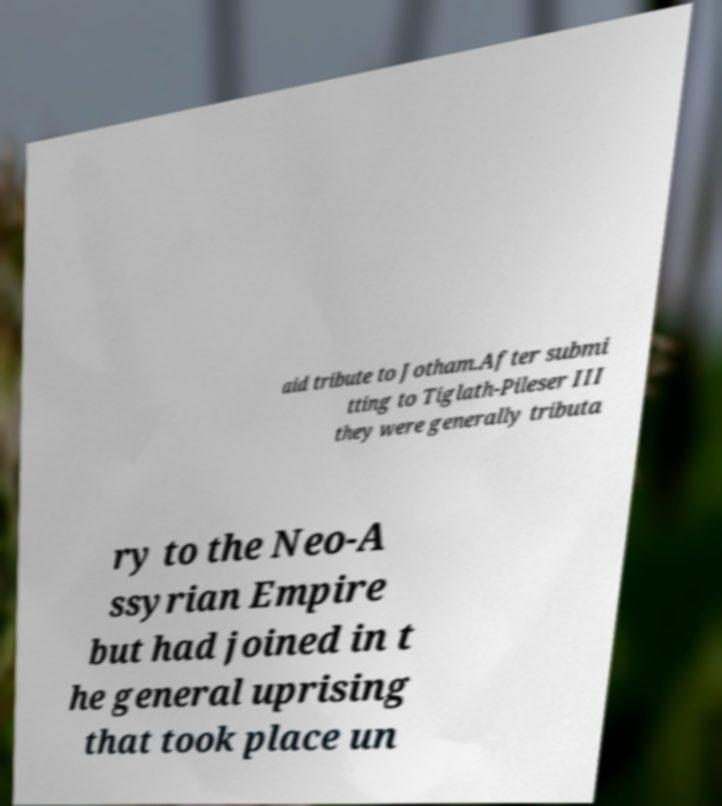For documentation purposes, I need the text within this image transcribed. Could you provide that? aid tribute to Jotham.After submi tting to Tiglath-Pileser III they were generally tributa ry to the Neo-A ssyrian Empire but had joined in t he general uprising that took place un 